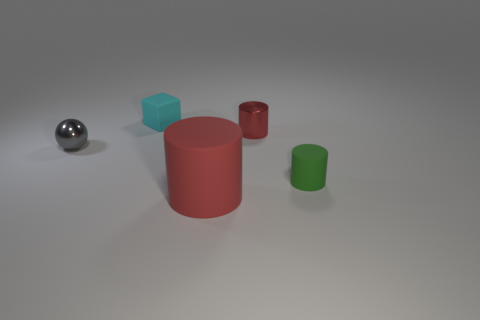There is a object that is both to the right of the red rubber thing and behind the green matte cylinder; what material is it made of?
Your answer should be compact. Metal. The big matte cylinder is what color?
Provide a succinct answer. Red. How many other objects are the same shape as the large object?
Offer a very short reply. 2. Is the number of green cylinders to the left of the green rubber cylinder the same as the number of red cylinders that are to the left of the big cylinder?
Provide a succinct answer. Yes. What is the material of the tiny green thing?
Keep it short and to the point. Rubber. What material is the tiny thing left of the block?
Your response must be concise. Metal. Is there any other thing that is the same material as the small block?
Your answer should be compact. Yes. Is the number of objects that are on the left side of the ball greater than the number of large blue blocks?
Give a very brief answer. No. There is a small cyan cube behind the matte cylinder that is in front of the green matte cylinder; is there a red cylinder behind it?
Offer a terse response. No. Are there any matte things left of the block?
Your answer should be compact. No. 